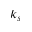<formula> <loc_0><loc_0><loc_500><loc_500>k _ { s }</formula> 